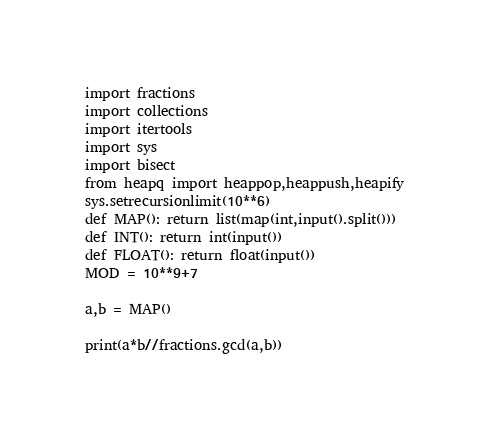<code> <loc_0><loc_0><loc_500><loc_500><_Python_>import fractions
import collections
import itertools
import sys
import bisect
from heapq import heappop,heappush,heapify
sys.setrecursionlimit(10**6)
def MAP(): return list(map(int,input().split()))
def INT(): return int(input())
def FLOAT(): return float(input())
MOD = 10**9+7

a,b = MAP()

print(a*b//fractions.gcd(a,b))</code> 